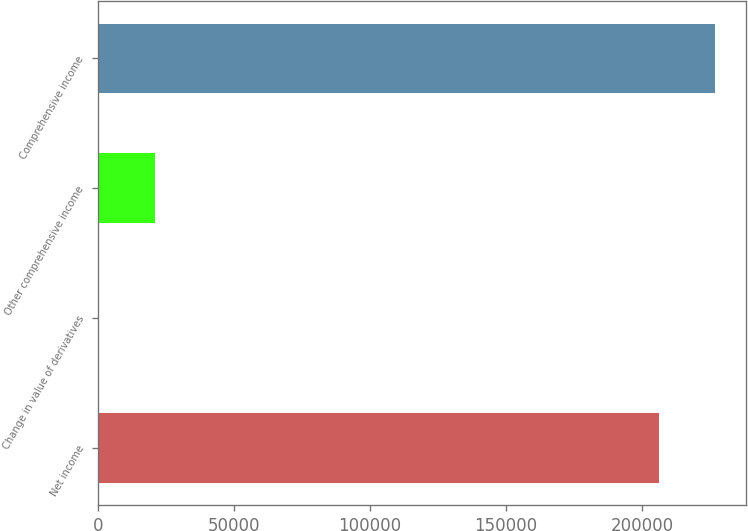Convert chart. <chart><loc_0><loc_0><loc_500><loc_500><bar_chart><fcel>Net income<fcel>Change in value of derivatives<fcel>Other comprehensive income<fcel>Comprehensive income<nl><fcel>206145<fcel>314<fcel>20928.5<fcel>226760<nl></chart> 